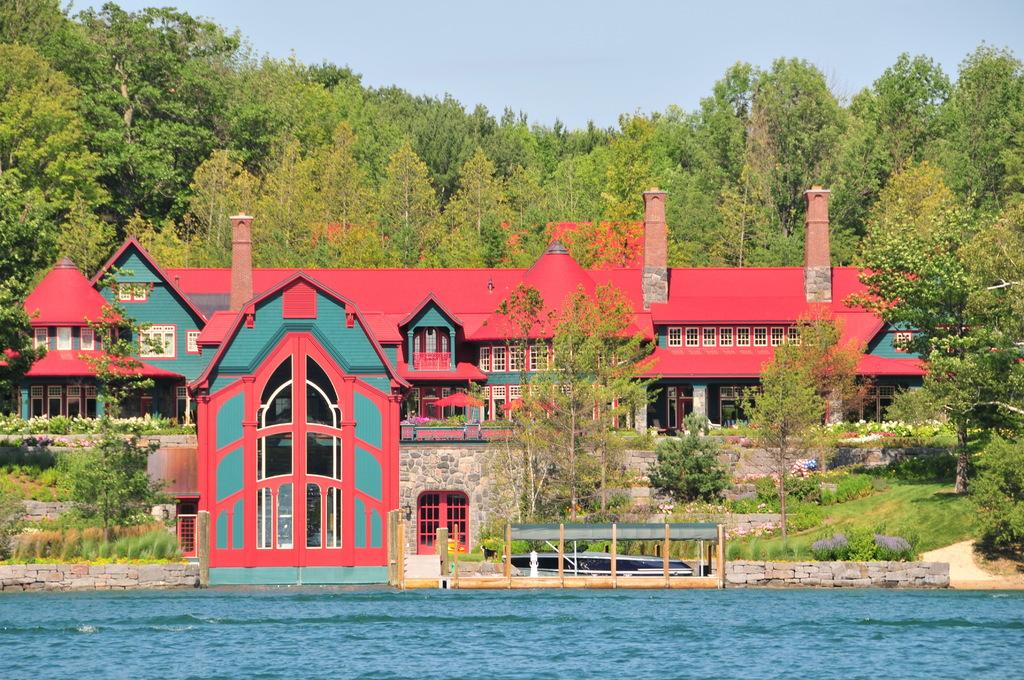What is visible in the image? Water is visible in the image. What can be seen in the background of the image? There is a building and trees in the background of the image. Can you describe the colors of the building? The building has green and pink colors. What is the color of the trees in the background? The trees are green in color. How would you describe the sky in the image? The sky is white in color. What type of desk can be seen in the image? There is no desk present in the image. What is being traded in the image? There is no trade or exchange of goods depicted in the image. 